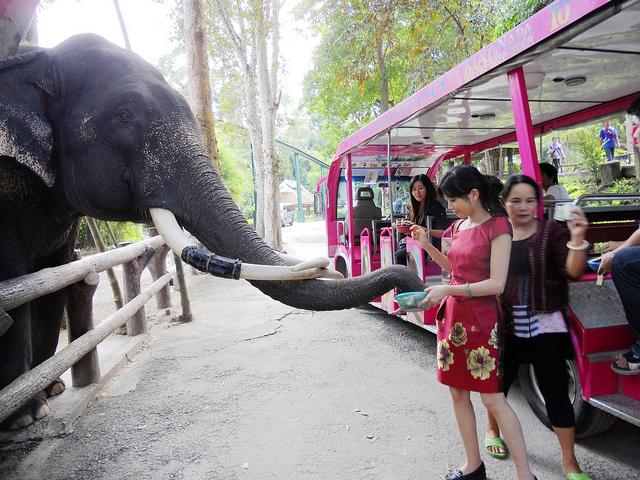What does the elephant seek? Please explain your reasoning. food. The elephant wants a treat. 